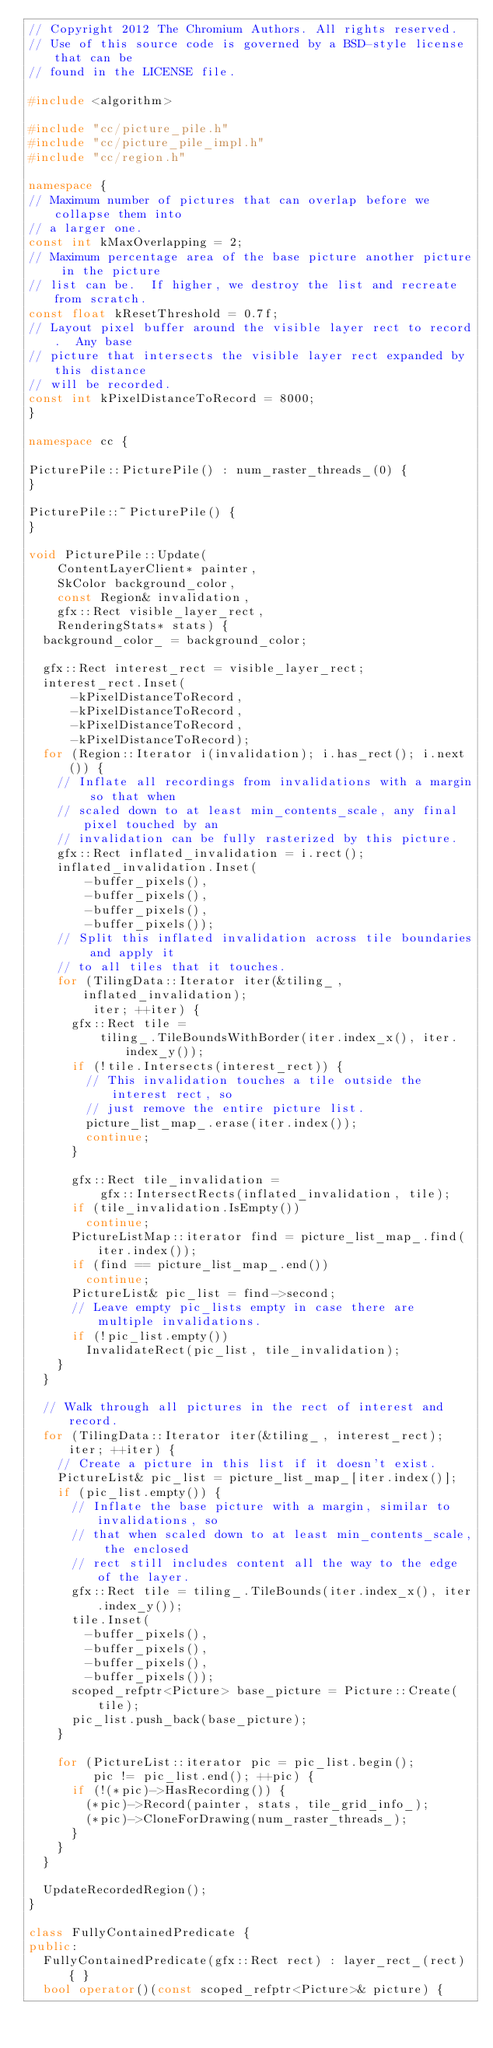Convert code to text. <code><loc_0><loc_0><loc_500><loc_500><_C++_>// Copyright 2012 The Chromium Authors. All rights reserved.
// Use of this source code is governed by a BSD-style license that can be
// found in the LICENSE file.

#include <algorithm>

#include "cc/picture_pile.h"
#include "cc/picture_pile_impl.h"
#include "cc/region.h"

namespace {
// Maximum number of pictures that can overlap before we collapse them into
// a larger one.
const int kMaxOverlapping = 2;
// Maximum percentage area of the base picture another picture in the picture
// list can be.  If higher, we destroy the list and recreate from scratch.
const float kResetThreshold = 0.7f;
// Layout pixel buffer around the visible layer rect to record.  Any base
// picture that intersects the visible layer rect expanded by this distance
// will be recorded.
const int kPixelDistanceToRecord = 8000;
}

namespace cc {

PicturePile::PicturePile() : num_raster_threads_(0) {
}

PicturePile::~PicturePile() {
}

void PicturePile::Update(
    ContentLayerClient* painter,
    SkColor background_color,
    const Region& invalidation,
    gfx::Rect visible_layer_rect,
    RenderingStats* stats) {
  background_color_ = background_color;

  gfx::Rect interest_rect = visible_layer_rect;
  interest_rect.Inset(
      -kPixelDistanceToRecord,
      -kPixelDistanceToRecord,
      -kPixelDistanceToRecord,
      -kPixelDistanceToRecord);
  for (Region::Iterator i(invalidation); i.has_rect(); i.next()) {
    // Inflate all recordings from invalidations with a margin so that when
    // scaled down to at least min_contents_scale, any final pixel touched by an
    // invalidation can be fully rasterized by this picture.
    gfx::Rect inflated_invalidation = i.rect();
    inflated_invalidation.Inset(
        -buffer_pixels(),
        -buffer_pixels(),
        -buffer_pixels(),
        -buffer_pixels());
    // Split this inflated invalidation across tile boundaries and apply it
    // to all tiles that it touches.
    for (TilingData::Iterator iter(&tiling_, inflated_invalidation);
         iter; ++iter) {
      gfx::Rect tile =
          tiling_.TileBoundsWithBorder(iter.index_x(), iter.index_y());
      if (!tile.Intersects(interest_rect)) {
        // This invalidation touches a tile outside the interest rect, so
        // just remove the entire picture list.
        picture_list_map_.erase(iter.index());
        continue;
      }

      gfx::Rect tile_invalidation =
          gfx::IntersectRects(inflated_invalidation, tile);
      if (tile_invalidation.IsEmpty())
        continue;
      PictureListMap::iterator find = picture_list_map_.find(iter.index());
      if (find == picture_list_map_.end())
        continue;
      PictureList& pic_list = find->second;
      // Leave empty pic_lists empty in case there are multiple invalidations.
      if (!pic_list.empty())
        InvalidateRect(pic_list, tile_invalidation);
    }
  }

  // Walk through all pictures in the rect of interest and record.
  for (TilingData::Iterator iter(&tiling_, interest_rect); iter; ++iter) {
    // Create a picture in this list if it doesn't exist.
    PictureList& pic_list = picture_list_map_[iter.index()];
    if (pic_list.empty()) {
      // Inflate the base picture with a margin, similar to invalidations, so
      // that when scaled down to at least min_contents_scale, the enclosed
      // rect still includes content all the way to the edge of the layer.
      gfx::Rect tile = tiling_.TileBounds(iter.index_x(), iter.index_y());
      tile.Inset(
        -buffer_pixels(),
        -buffer_pixels(),
        -buffer_pixels(),
        -buffer_pixels());
      scoped_refptr<Picture> base_picture = Picture::Create(tile);
      pic_list.push_back(base_picture);
    }

    for (PictureList::iterator pic = pic_list.begin();
         pic != pic_list.end(); ++pic) {
      if (!(*pic)->HasRecording()) {
        (*pic)->Record(painter, stats, tile_grid_info_);
        (*pic)->CloneForDrawing(num_raster_threads_);
      }
    }
  }

  UpdateRecordedRegion();
}

class FullyContainedPredicate {
public:
  FullyContainedPredicate(gfx::Rect rect) : layer_rect_(rect) { }
  bool operator()(const scoped_refptr<Picture>& picture) {</code> 